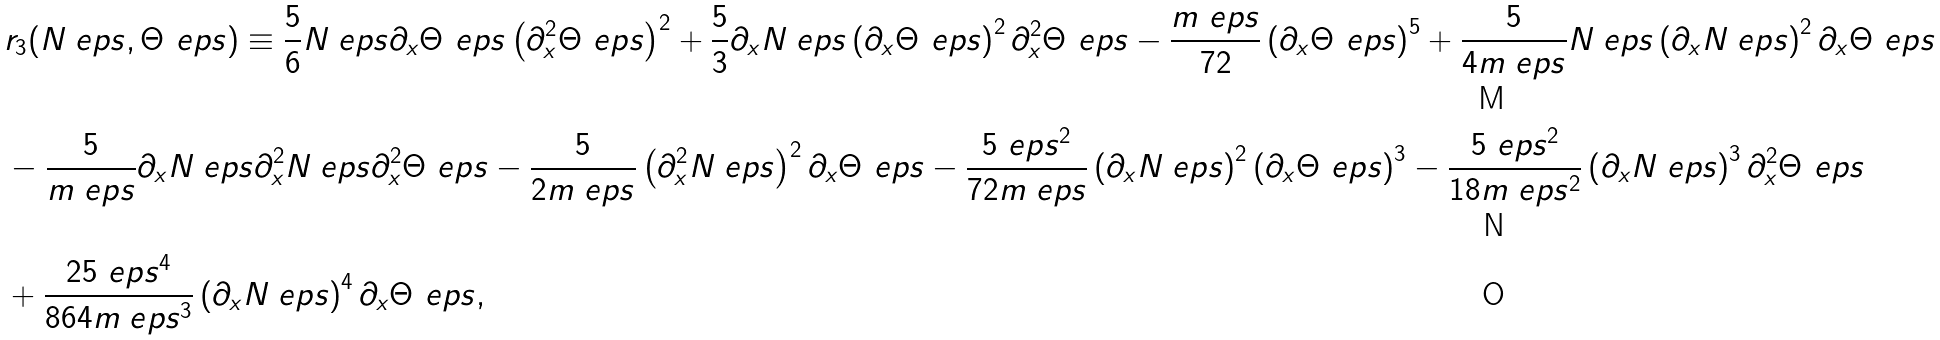Convert formula to latex. <formula><loc_0><loc_0><loc_500><loc_500>& r _ { 3 } ( N _ { \ } e p s , \Theta _ { \ } e p s ) \equiv \frac { 5 } { 6 } N _ { \ } e p s \partial _ { x } \Theta _ { \ } e p s \left ( \partial _ { x } ^ { 2 } \Theta _ { \ } e p s \right ) ^ { 2 } + \frac { 5 } { 3 } \partial _ { x } N _ { \ } e p s \left ( \partial _ { x } \Theta _ { \ } e p s \right ) ^ { 2 } \partial _ { x } ^ { 2 } \Theta _ { \ } e p s - \frac { m _ { \ } e p s } { 7 2 } \left ( \partial _ { x } \Theta _ { \ } e p s \right ) ^ { 5 } + \frac { 5 } { 4 m _ { \ } e p s } N _ { \ } e p s \left ( \partial _ { x } N _ { \ } e p s \right ) ^ { 2 } \partial _ { x } \Theta _ { \ } e p s \\ & - \frac { 5 } { m _ { \ } e p s } \partial _ { x } N _ { \ } e p s \partial _ { x } ^ { 2 } N _ { \ } e p s \partial _ { x } ^ { 2 } \Theta _ { \ } e p s - \frac { 5 } { 2 m _ { \ } e p s } \left ( \partial _ { x } ^ { 2 } N _ { \ } e p s \right ) ^ { 2 } \partial _ { x } \Theta _ { \ } e p s - \frac { 5 \ e p s ^ { 2 } } { 7 2 m _ { \ } e p s } \left ( \partial _ { x } N _ { \ } e p s \right ) ^ { 2 } \left ( \partial _ { x } \Theta _ { \ } e p s \right ) ^ { 3 } - \frac { 5 \ e p s ^ { 2 } } { 1 8 m _ { \ } e p s ^ { 2 } } \left ( \partial _ { x } N _ { \ } e p s \right ) ^ { 3 } \partial _ { x } ^ { 2 } \Theta _ { \ } e p s \\ & + \frac { 2 5 \ e p s ^ { 4 } } { 8 6 4 m _ { \ } e p s ^ { 3 } } \left ( \partial _ { x } N _ { \ } e p s \right ) ^ { 4 } \partial _ { x } \Theta _ { \ } e p s ,</formula> 